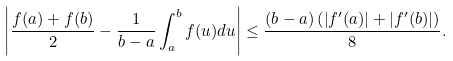<formula> <loc_0><loc_0><loc_500><loc_500>\left | \frac { f ( a ) + f ( b ) } { 2 } - \frac { 1 } { b - a } \int _ { a } ^ { b } f ( u ) d u \right | \leq \frac { ( b - a ) \left ( \left | f ^ { \prime } ( a ) \right | + \left | f ^ { \prime } ( b ) \right | \right ) } { 8 } .</formula> 